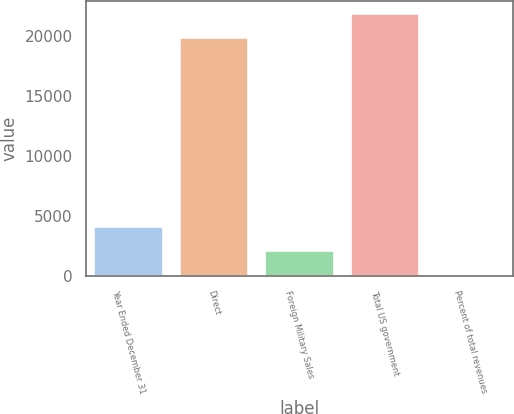Convert chart. <chart><loc_0><loc_0><loc_500><loc_500><bar_chart><fcel>Year Ended December 31<fcel>Direct<fcel>Foreign Military Sales<fcel>Total US government<fcel>Percent of total revenues<nl><fcel>4084.4<fcel>19864<fcel>2076.7<fcel>21871.7<fcel>69<nl></chart> 